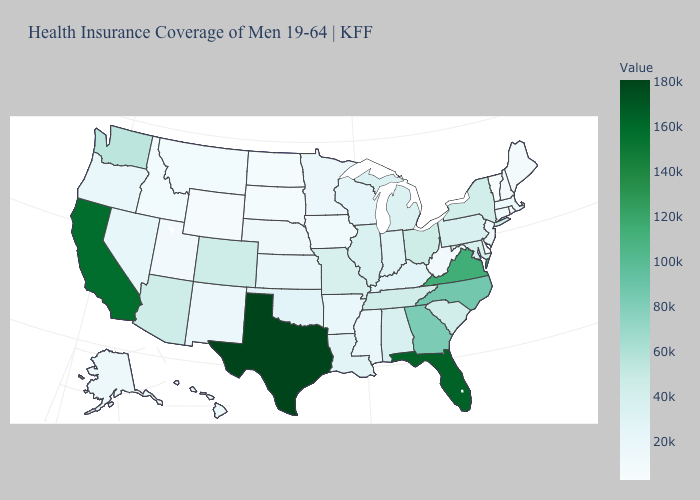Is the legend a continuous bar?
Keep it brief. Yes. Which states hav the highest value in the MidWest?
Answer briefly. Ohio. Does Delaware have the lowest value in the USA?
Short answer required. No. Which states have the lowest value in the Northeast?
Write a very short answer. Vermont. Does Arkansas have the lowest value in the South?
Quick response, please. No. Among the states that border Ohio , which have the lowest value?
Answer briefly. West Virginia. Among the states that border North Dakota , which have the lowest value?
Short answer required. South Dakota. Which states have the highest value in the USA?
Concise answer only. Texas. 